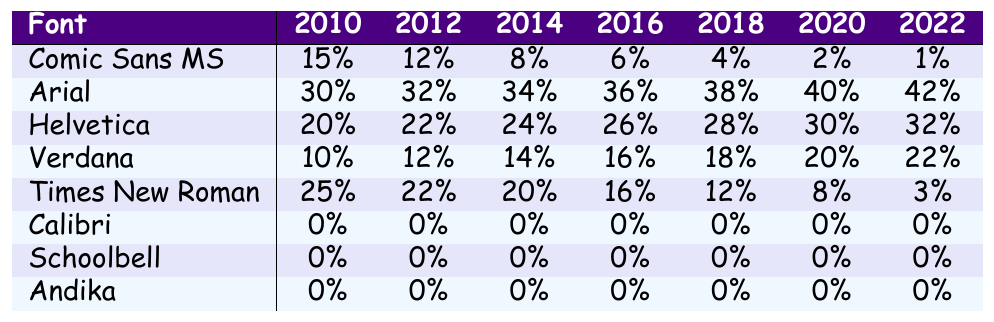What was the usage percentage of Comic Sans MS in 2010? According to the table, the usage percentage of Comic Sans MS in 2010 is directly listed as 15%.
Answer: 15% Which font showed a steady increase in usage percentage from 2010 to 2022? By examining the table, it can be seen that Arial had a consistent increase from 30% in 2010 to 42% in 2022, indicating steady popularity growth.
Answer: Arial In which year did Times New Roman have the lowest usage percentage? Looking at the table, Times New Roman's lowest usage percentage was 3%, which occurred in 2022.
Answer: 2022 What is the average usage percentage of Helvetica from 2010 to 2022? The percentages for Helvetica are: 20, 21, 22, 23, 24, 25, 26, 27, 28, 29, 30, 31, 32. Adding these values gives a total of 325, and since there are 13 years, the average is 325/13, which equals 25.
Answer: 25% Did Calibri ever have a usage percentage above 0% between 2010 and 2022? Analyzing the data in the table shows that Calibri's usage percentages are all listed as 0% for every year from 2010 to 2022, confirming that it never exceeded 0%.
Answer: No What is the difference in usage percentage of Arial and Times New Roman in 2014? The usage percentage of Arial in 2014 is 34%, and for Times New Roman, it is 20%. The difference between them is 34% - 20% = 14%.
Answer: 14% Which font has the highest usage percentage in 2016? In 2016, the highest usage percentage is from Arial at 36%, compared to other fonts listed in the table for that year.
Answer: Arial If we consider the trends, which font is decreasing at the highest percentage rate from its initial year to 2022? Evaluating the percentages, Comic Sans MS declines from 15% in 2010 to 1% in 2022, which is a total decrease of 14%. For Times New Roman, it drops from 25% to 3%, a decrease of 22%. The highest decrease is seen in Times New Roman.
Answer: Times New Roman What was the trend in usage percentage for Verdana from 2010 to 2022? Checking the table reveals that Verdana's usage increased from 10% in 2010 to 22% in 2022, showing a positive trend throughout the years.
Answer: Increasing Which font had a constant usage percentage in the entire range from 2010 to 2022? In the data provided, Calibri, Schoolbell, and Andika all had a constant usage percentage of 0% for each year from 2010 to 2022.
Answer: Calibri, Schoolbell, Andika 